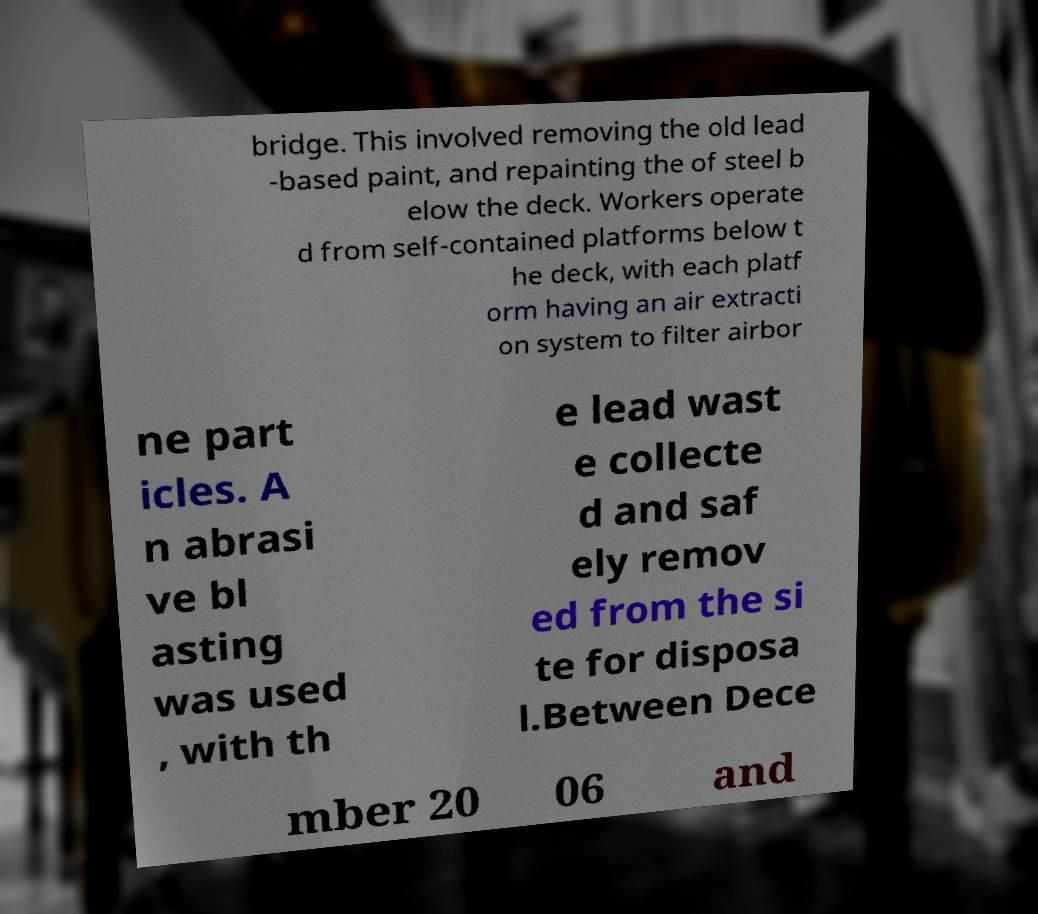Please identify and transcribe the text found in this image. bridge. This involved removing the old lead -based paint, and repainting the of steel b elow the deck. Workers operate d from self-contained platforms below t he deck, with each platf orm having an air extracti on system to filter airbor ne part icles. A n abrasi ve bl asting was used , with th e lead wast e collecte d and saf ely remov ed from the si te for disposa l.Between Dece mber 20 06 and 